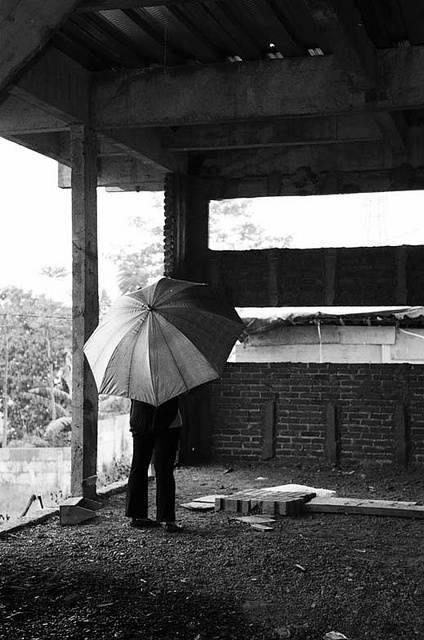Describe the objects in this image and their specific colors. I can see umbrella in black, gray, darkgray, and lightgray tones and people in black, gray, and lightgray tones in this image. 